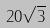Convert formula to latex. <formula><loc_0><loc_0><loc_500><loc_500>2 0 \sqrt { 3 }</formula> 